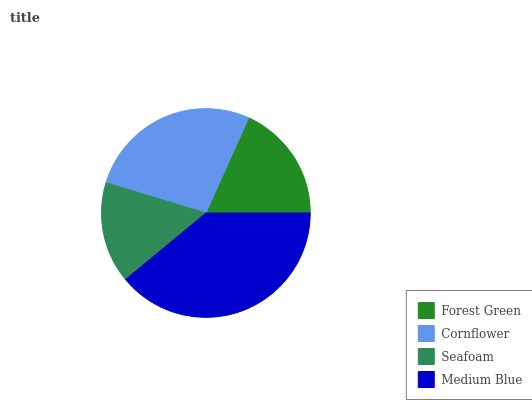Is Seafoam the minimum?
Answer yes or no. Yes. Is Medium Blue the maximum?
Answer yes or no. Yes. Is Cornflower the minimum?
Answer yes or no. No. Is Cornflower the maximum?
Answer yes or no. No. Is Cornflower greater than Forest Green?
Answer yes or no. Yes. Is Forest Green less than Cornflower?
Answer yes or no. Yes. Is Forest Green greater than Cornflower?
Answer yes or no. No. Is Cornflower less than Forest Green?
Answer yes or no. No. Is Cornflower the high median?
Answer yes or no. Yes. Is Forest Green the low median?
Answer yes or no. Yes. Is Medium Blue the high median?
Answer yes or no. No. Is Medium Blue the low median?
Answer yes or no. No. 